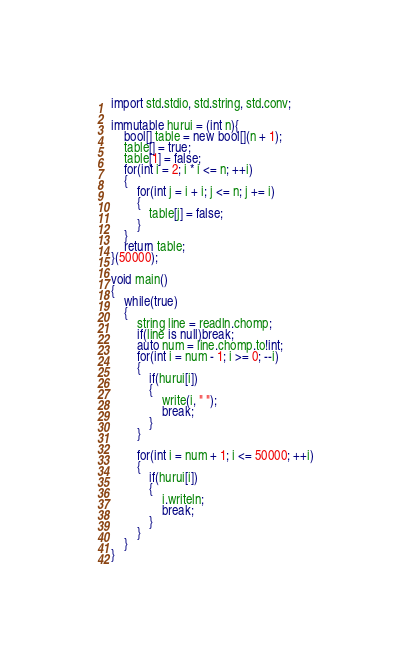<code> <loc_0><loc_0><loc_500><loc_500><_D_>import std.stdio, std.string, std.conv;

immutable hurui = (int n){
    bool[] table = new bool[](n + 1);
    table[] = true;
    table[1] = false;
    for(int i = 2; i * i <= n; ++i)
    {
        for(int j = i + i; j <= n; j += i)
        {
            table[j] = false;
        }
    }
    return table;
}(50000);

void main()
{
    while(true)
    {
        string line = readln.chomp;
        if(line is null)break;
        auto num = line.chomp.to!int;
        for(int i = num - 1; i >= 0; --i)
        {
            if(hurui[i])
            {
                write(i, " ");
                break;
            }
        }

        for(int i = num + 1; i <= 50000; ++i)
        {
            if(hurui[i])
            {
                i.writeln;
                break;
            }
        }
    }
}</code> 